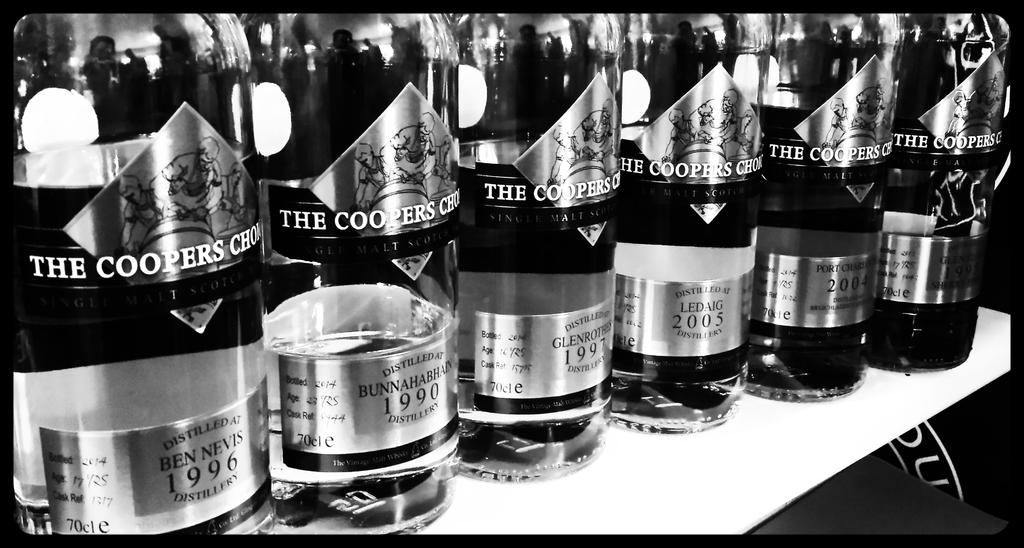<image>
Relay a brief, clear account of the picture shown. the name Coopers is on the front of some wine 